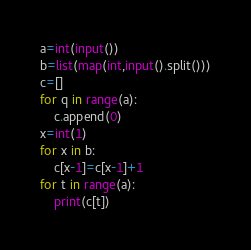<code> <loc_0><loc_0><loc_500><loc_500><_Python_>a=int(input())
b=list(map(int,input().split()))
c=[]
for q in range(a):
    c.append(0)
x=int(1)
for x in b:
    c[x-1]=c[x-1]+1
for t in range(a):
    print(c[t])</code> 